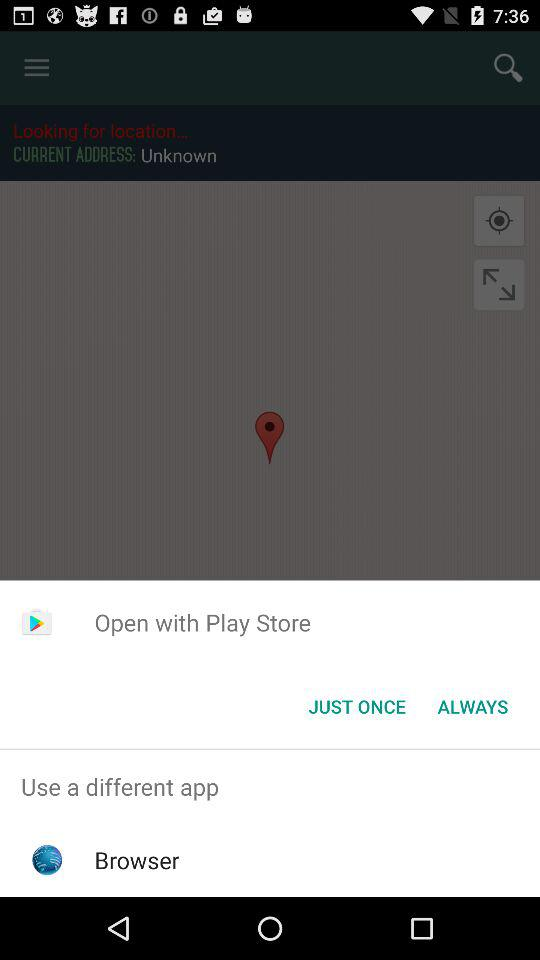With which app can we open it? You can open it with "Play Store" and "Browser". 